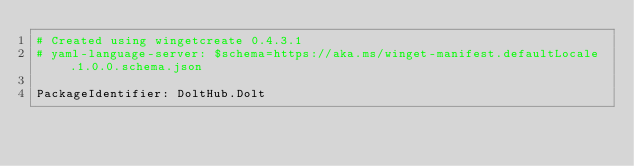<code> <loc_0><loc_0><loc_500><loc_500><_YAML_># Created using wingetcreate 0.4.3.1
# yaml-language-server: $schema=https://aka.ms/winget-manifest.defaultLocale.1.0.0.schema.json

PackageIdentifier: DoltHub.Dolt</code> 